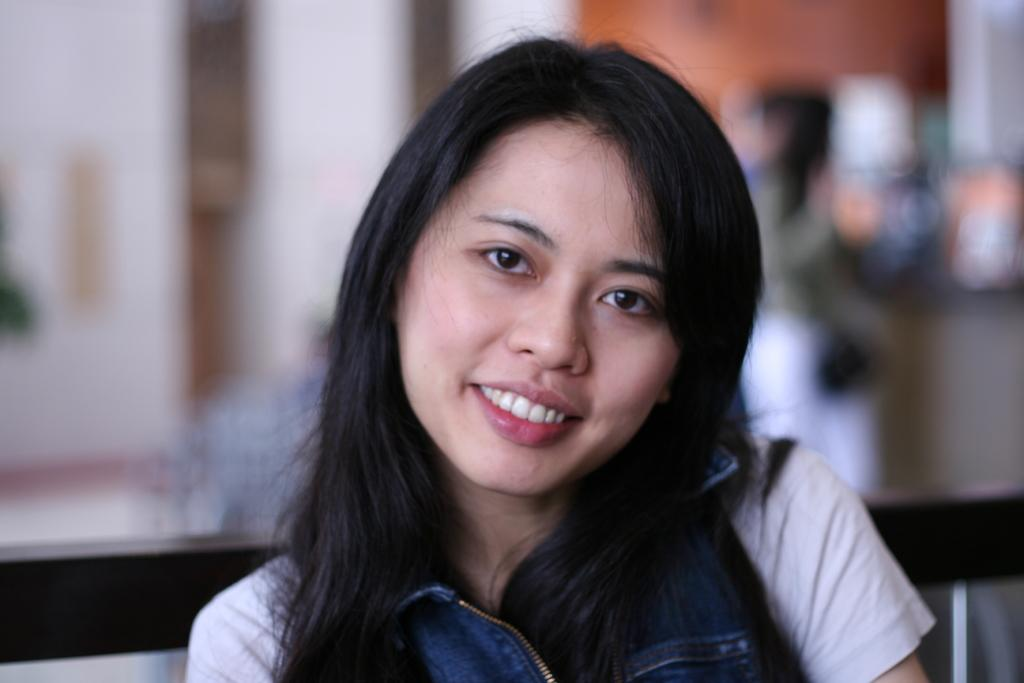Who is the main subject in the image? There is a lady in the image. What is the lady wearing? The lady is wearing a white and blue dress. What is the lady's facial expression? The lady is smiling. Can you describe the background of the image? The background of the image is blurred. What type of stone can be seen in the lady's hand in the image? There is no stone present in the lady's hand or in the image. 